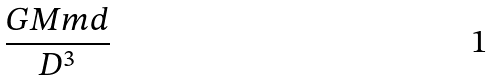<formula> <loc_0><loc_0><loc_500><loc_500>\frac { G M m d } { D ^ { 3 } }</formula> 